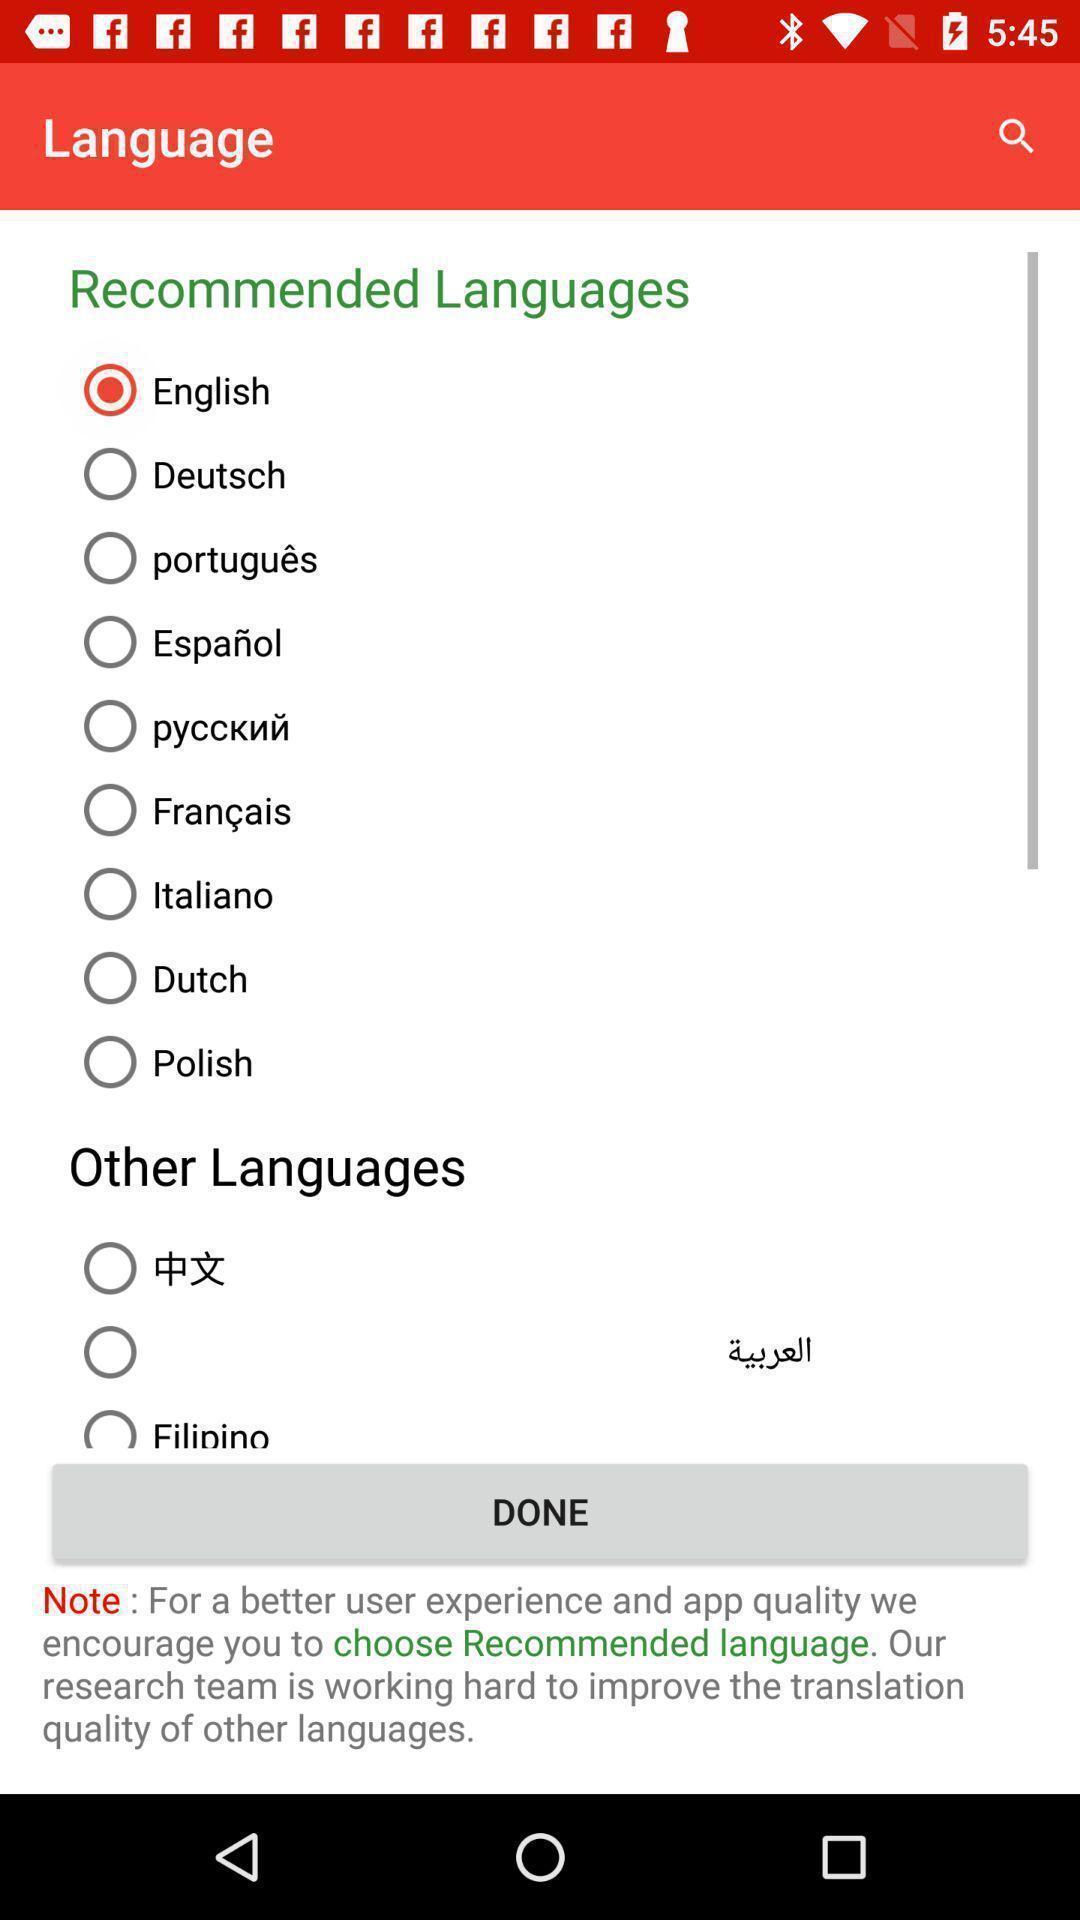Describe this image in words. Screen displaying a list of language names. 